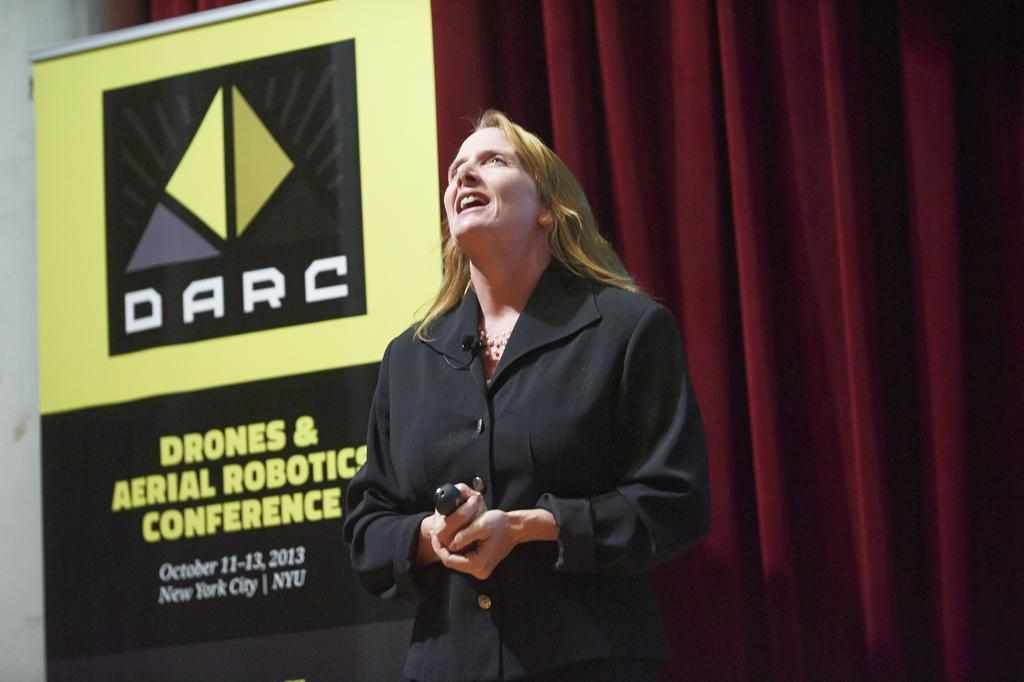What is the main subject of the image? There is a person in the image. What is the person doing in the image? The person is holding an object and standing. Can you describe the board in the image? There is a board with text and an image in the image. What else can be seen in the background of the image? There is a curtain visible in the image. How many bikes are parked in front of the person in the image? There are no bikes visible in the image. Can you describe the type of sand in the image? There is no sand present in the image. 